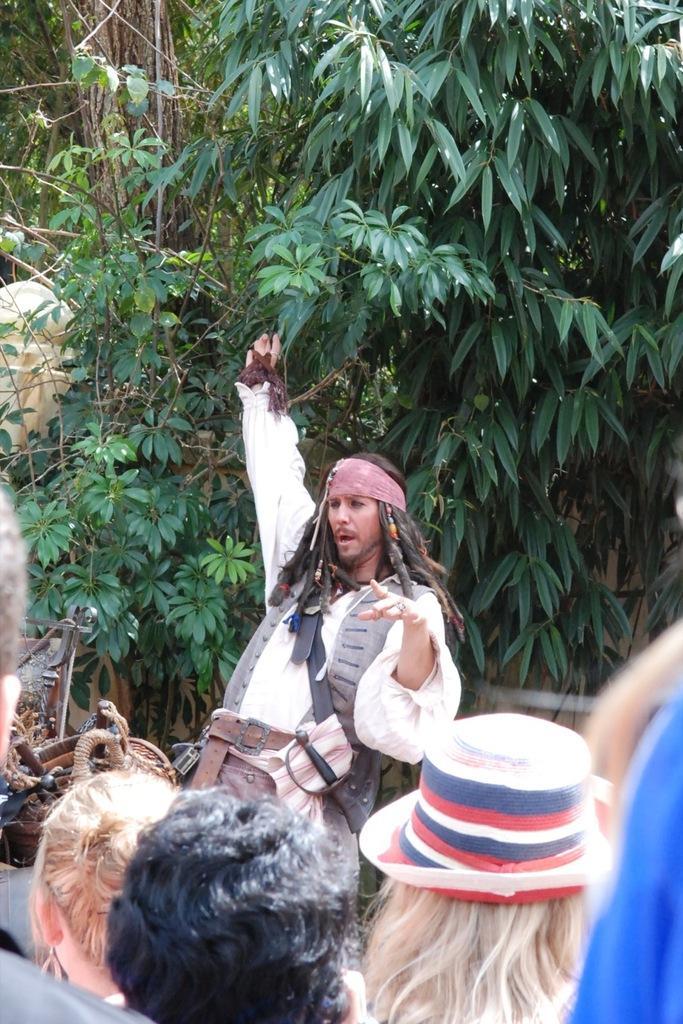Please provide a concise description of this image. In this picture there are people and we can see trees and few objects. 